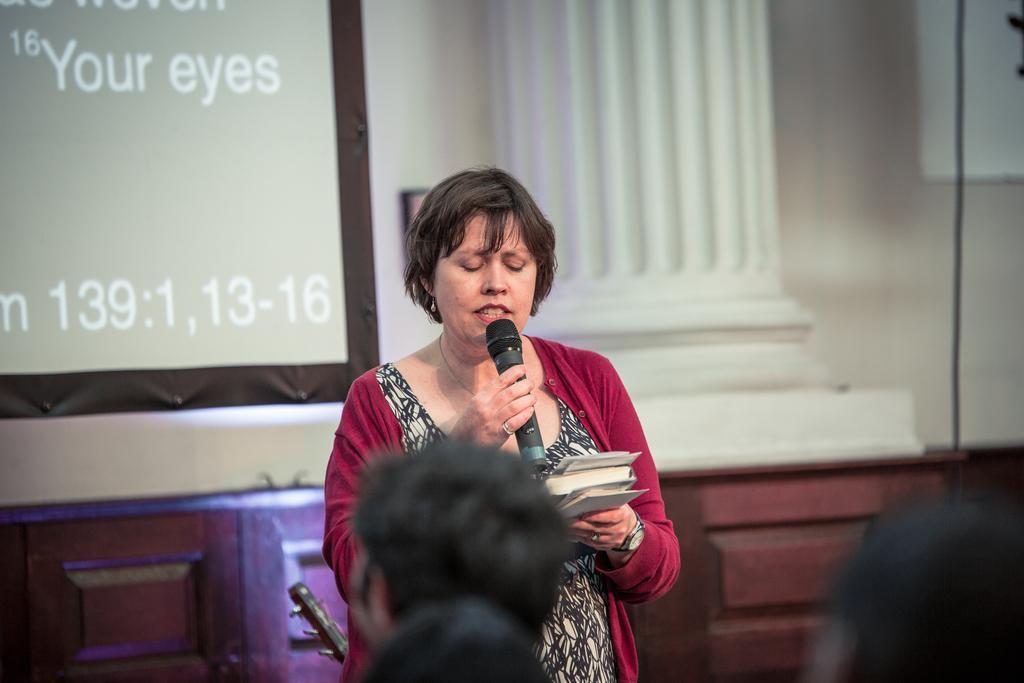Can you describe this image briefly? In the picture we can see a woman standing and holding a microphone and in the other hand she is holding some papers and talking something in front of her we can see some people are sitting and behind her we can see a wall with a board and beside it we can see a pillar and under it we can see some wooden frame. 